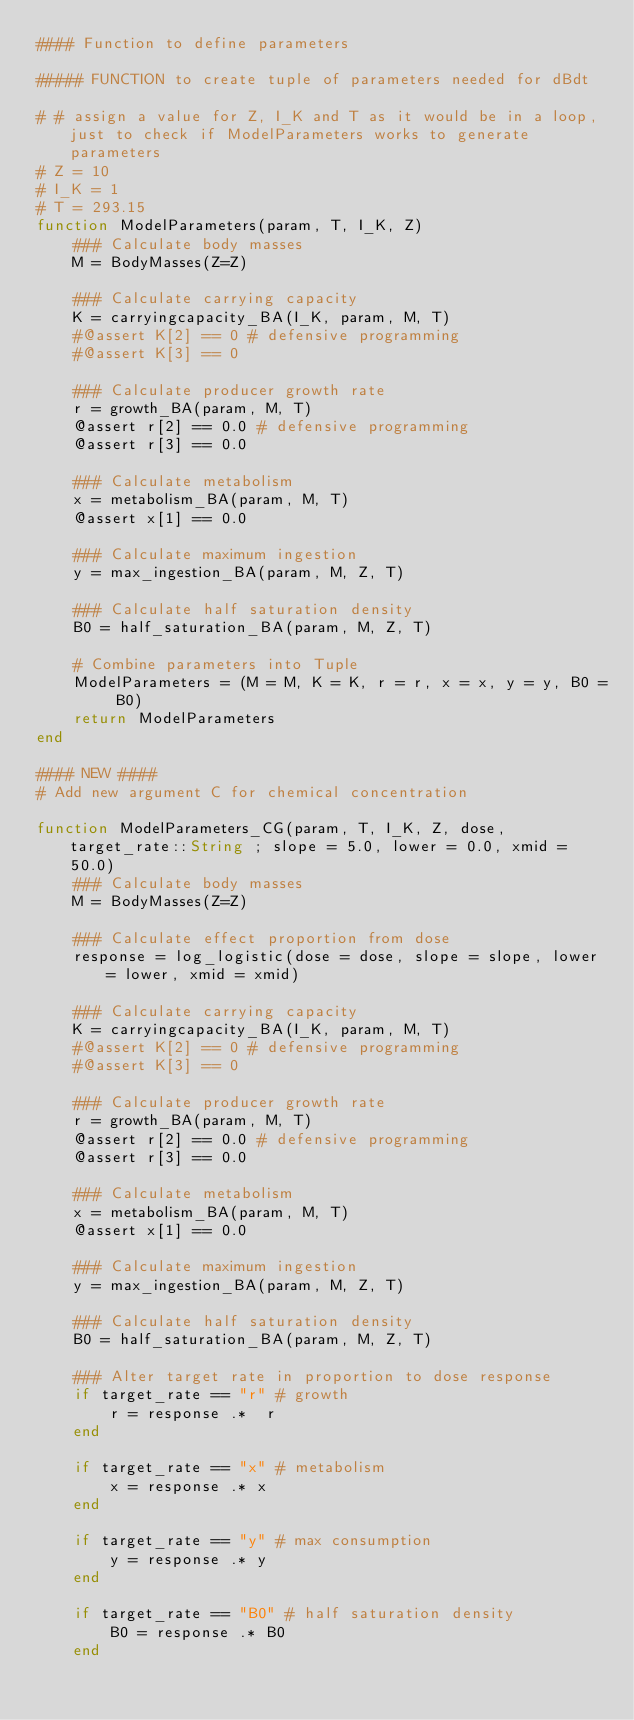<code> <loc_0><loc_0><loc_500><loc_500><_Julia_>#### Function to define parameters 

##### FUNCTION to create tuple of parameters needed for dBdt 

# # assign a value for Z, I_K and T as it would be in a loop, just to check if ModelParameters works to generate parameters
# Z = 10
# I_K = 1
# T = 293.15
function ModelParameters(param, T, I_K, Z)
    ### Calculate body masses
    M = BodyMasses(Z=Z)

    ### Calculate carrying capacity
    K = carryingcapacity_BA(I_K, param, M, T)
    #@assert K[2] == 0 # defensive programming
    #@assert K[3] == 0 

    ### Calculate producer growth rate
    r = growth_BA(param, M, T)
    @assert r[2] == 0.0 # defensive programming
    @assert r[3] == 0.0 

    ### Calculate metabolism
    x = metabolism_BA(param, M, T)
    @assert x[1] == 0.0

    ### Calculate maximum ingestion
    y = max_ingestion_BA(param, M, Z, T)

    ### Calculate half saturation density
    B0 = half_saturation_BA(param, M, Z, T)

    # Combine parameters into Tuple
    ModelParameters = (M = M, K = K, r = r, x = x, y = y, B0 = B0)
    return ModelParameters
end

#### NEW ####
# Add new argument C for chemical concentration

function ModelParameters_CG(param, T, I_K, Z, dose, target_rate::String ; slope = 5.0, lower = 0.0, xmid = 50.0)
    ### Calculate body masses
    M = BodyMasses(Z=Z)

    ### Calculate effect proportion from dose
    response = log_logistic(dose = dose, slope = slope, lower = lower, xmid = xmid)
    
    ### Calculate carrying capacity
    K = carryingcapacity_BA(I_K, param, M, T)
    #@assert K[2] == 0 # defensive programming
    #@assert K[3] == 0 

    ### Calculate producer growth rate
    r = growth_BA(param, M, T)
    @assert r[2] == 0.0 # defensive programming
    @assert r[3] == 0.0 

    ### Calculate metabolism
    x = metabolism_BA(param, M, T)
    @assert x[1] == 0.0

    ### Calculate maximum ingestion
    y = max_ingestion_BA(param, M, Z, T)

    ### Calculate half saturation density
    B0 = half_saturation_BA(param, M, Z, T)

    ### Alter target rate in proportion to dose response
    if target_rate == "r" # growth
        r = response .*  r
    end

    if target_rate == "x" # metabolism
        x = response .* x
    end

    if target_rate == "y" # max consumption
        y = response .* y 
    end

    if target_rate == "B0" # half saturation density
        B0 = response .* B0 
    end
</code> 